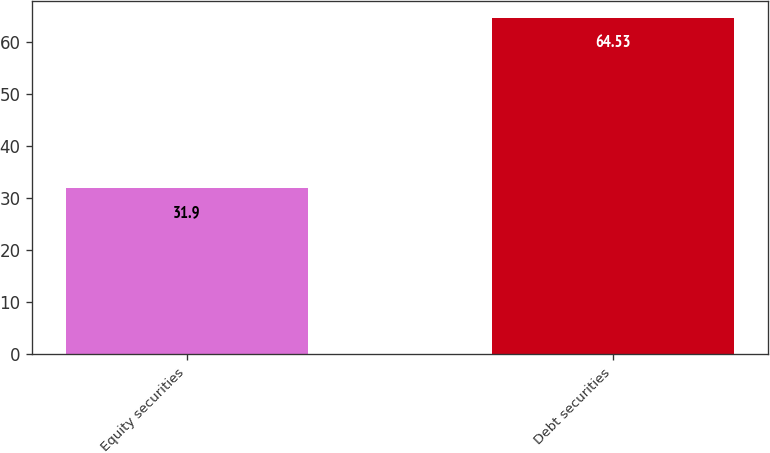Convert chart. <chart><loc_0><loc_0><loc_500><loc_500><bar_chart><fcel>Equity securities<fcel>Debt securities<nl><fcel>31.9<fcel>64.53<nl></chart> 